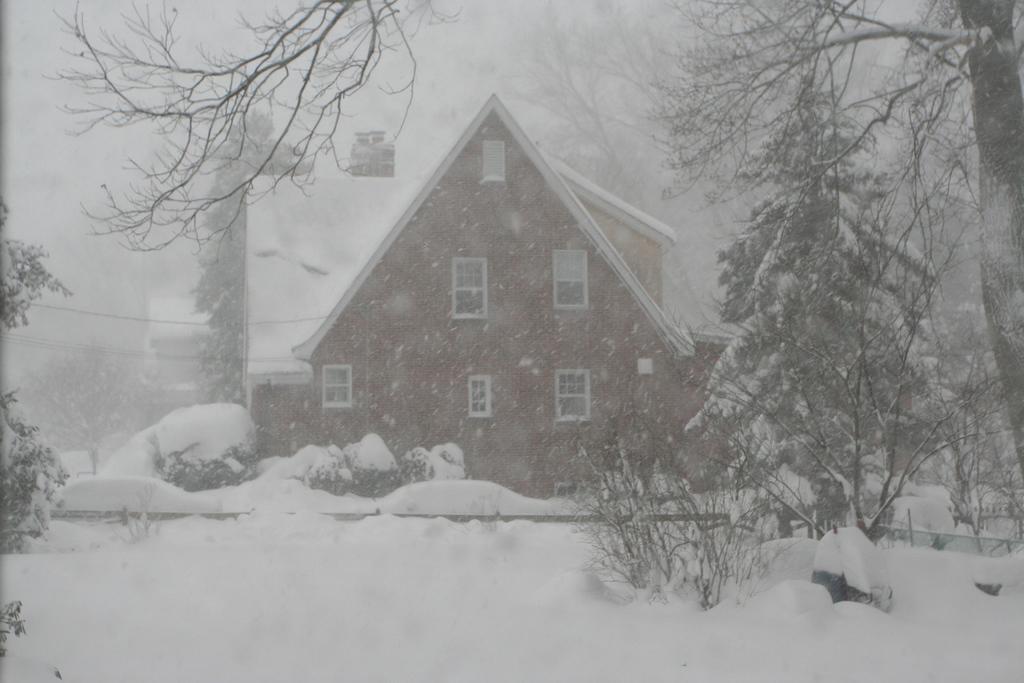How would you summarize this image in a sentence or two? In the image we can see a building and the windows of the building. Everywhere there is a snow white in color, we can see there are even trees. 